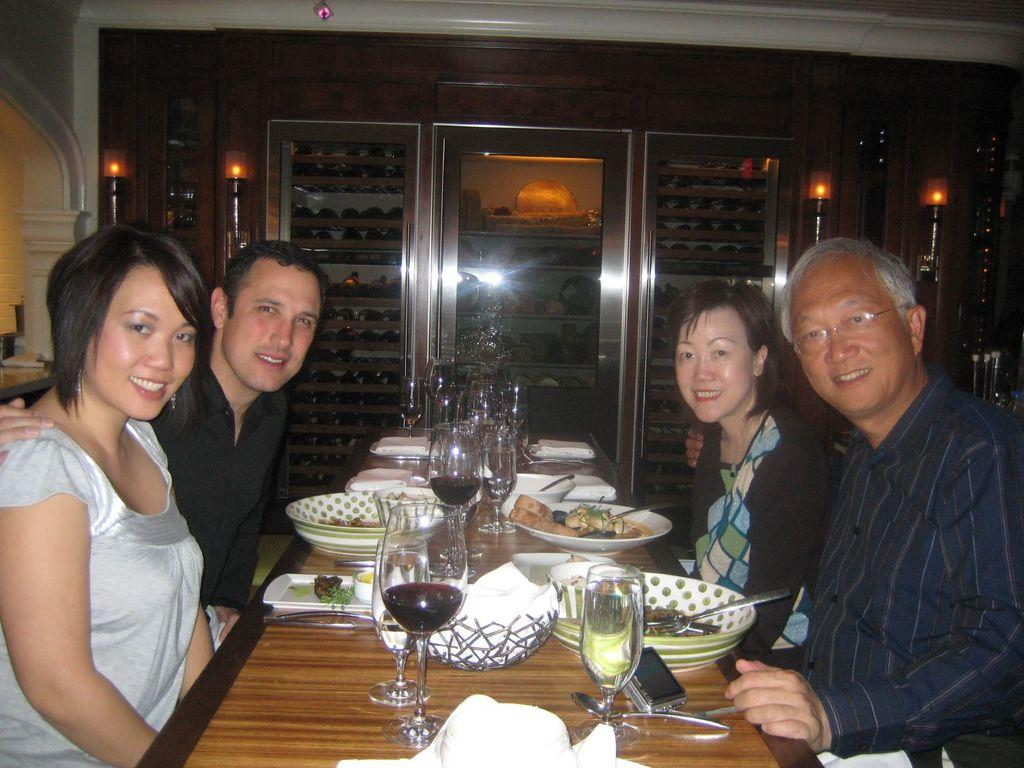What are the people in the image doing? The people in the image are sitting around a table. What objects are on the table with the people? There are glasses and plates on the table. What can be seen in the background of the image? There are shelves visible in the image. What type of lighting is present in the image? There are lights in the image. Can you see any grass growing on the table in the image? No, there is no grass visible on the table in the image. 